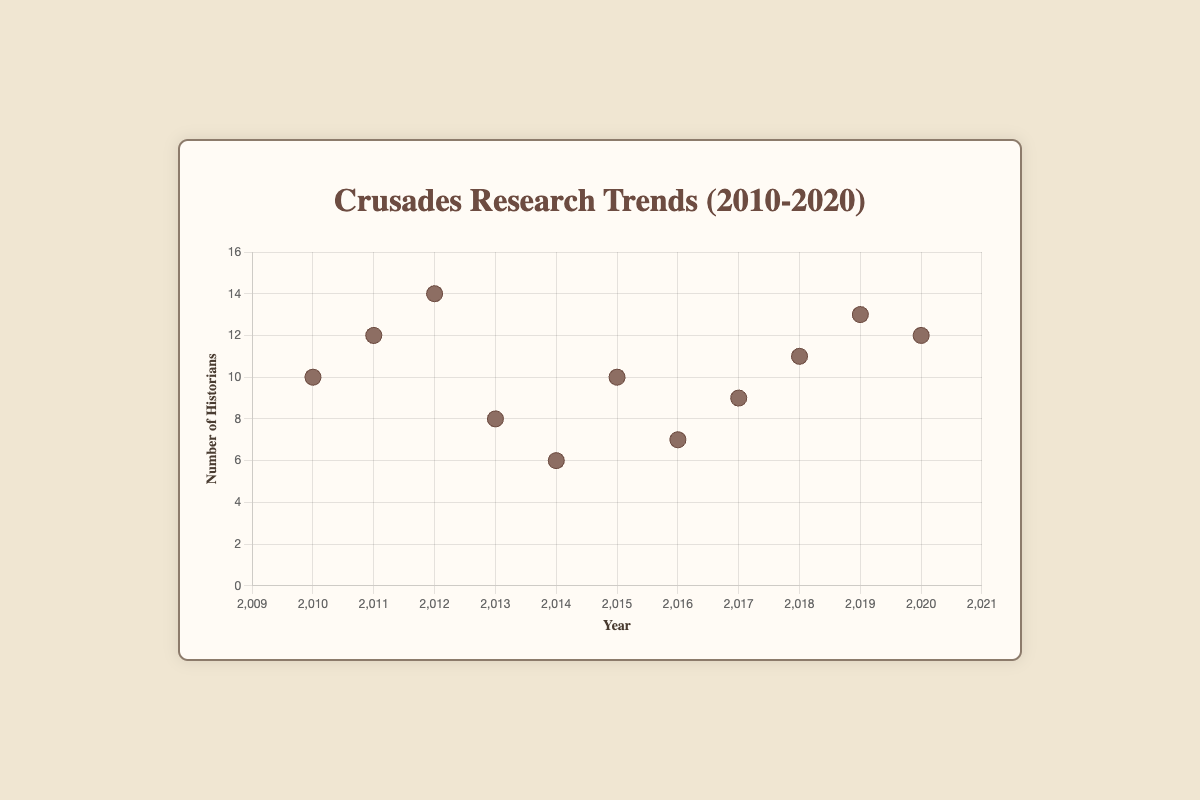How many historians were researching the First Crusade in 2010? The scatter plot indicates each data point clearly, and by looking at the point corresponding to the year 2010, we see 10 historians researching the First Crusade.
Answer: 10 Which year had the highest number of historians researching the Third Crusade? By examining the scatter plot, the year corresponding to the highest number of historians for the Third Crusade is 2012 at 14 historians.
Answer: 2012 What is the trend in the number of historians over the years 2010 to 2020? Analyzing the scatter points from 2010 to 2020, we can observe an overall fluctuation in the number of historians with minor rises and falls, reaching a notable peak in 2012 and stabilizing in 2019 and 2020.
Answer: Fluctuating How does the number of historians researching the Albigensian Crusade in 2013 compare to those researching the Children’s Crusade in 2014? Look at the data points for 2013 and 2014. 2013 shows 8 historians for the Albigensian Crusade and 2014 shows 6 historians for the Children’s Crusade, making 2013 have more historians.
Answer: 2013 > 2014 What is the median number of historians researching different Crusades from 2010 to 2020? To find the median: (10, 12, 14, 8, 6, 10, 7, 9, 11, 13, 12), sort these values: (6, 7, 8, 9, 10, 10, 11, 12, 12, 13, 14), the median value, being the central figure in this ordered set, is 10.
Answer: 10 Could you determine the research topic that had the least number of historians in any single year within the given decade? Scan the Y-axis values; the minimum value is 6, which corresponds to 2014 for the Children's Crusade.
Answer: Children's Crusade In what year did the number of historians researching the Barons' Crusade peak, and what was that number? Locate the data point for the Barons' Crusade, which is marked in 2019, record its number of historians, which is 13.
Answer: 2019, 13 How many total historians were there across all research topics in 2012 and 2018? Sum the historians for these years: 2012 has 14, and 2018 has 11, making the total 14 + 11 = 25.
Answer: 25 Which year saw the highest diversity in research topics, and what criterion leads to this conclusion? Each year is represented once by different historians, making the unique topic count uniformly distributed. Since each year had a distinct research topic, diversity is equal for all years.
Answer: All years equal How many years had fewer than 10 historians researching a particular Crusade? By inspecting the y-values: 2013 (8), 2014 (6), 2016 (7), and 2017 (9) result in four separate years with values under 10.
Answer: 4 